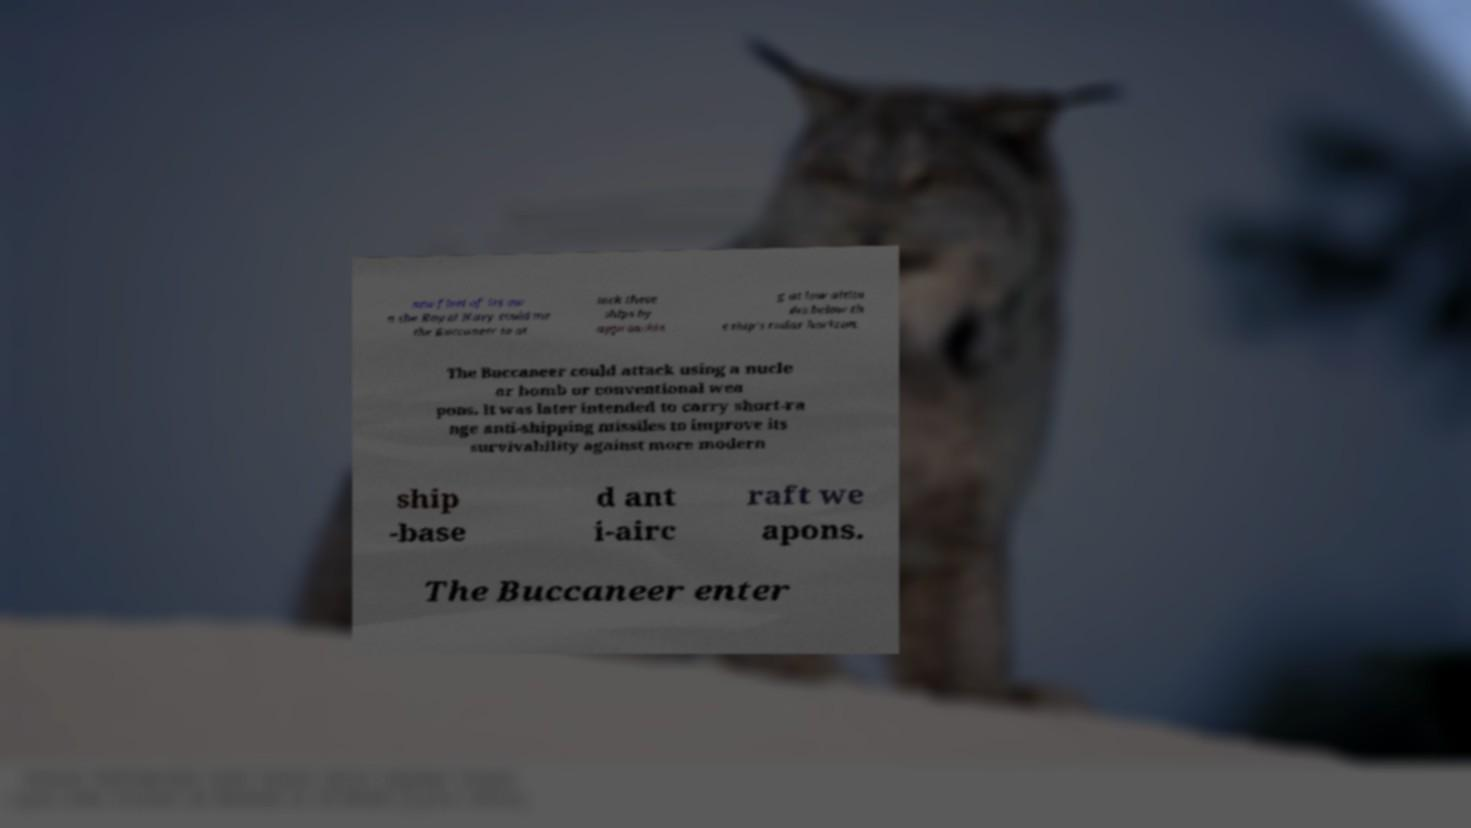Can you accurately transcribe the text from the provided image for me? new fleet of its ow n the Royal Navy could use the Buccaneer to at tack these ships by approachin g at low altitu des below th e ship's radar horizon. The Buccaneer could attack using a nucle ar bomb or conventional wea pons. It was later intended to carry short-ra nge anti-shipping missiles to improve its survivability against more modern ship -base d ant i-airc raft we apons. The Buccaneer enter 